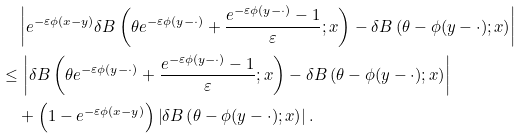<formula> <loc_0><loc_0><loc_500><loc_500>& \left | e ^ { - \varepsilon \phi ( x - y ) } \delta B \left ( \theta e ^ { - \varepsilon \phi ( y - \cdot ) } + \frac { e ^ { - \varepsilon \phi ( y - \cdot ) } - 1 } { \varepsilon } ; x \right ) - \delta B \left ( \theta - \phi ( y - \cdot ) ; x \right ) \right | \\ \leq & \, \left | \delta B \left ( \theta e ^ { - \varepsilon \phi ( y - \cdot ) } + \frac { e ^ { - \varepsilon \phi ( y - \cdot ) } - 1 } { \varepsilon } ; x \right ) - \delta B \left ( \theta - \phi ( y - \cdot ) ; x \right ) \right | \\ & + \left ( 1 - e ^ { - \varepsilon \phi ( x - y ) } \right ) \left | \delta B \left ( \theta - \phi ( y - \cdot ) ; x \right ) \right | .</formula> 